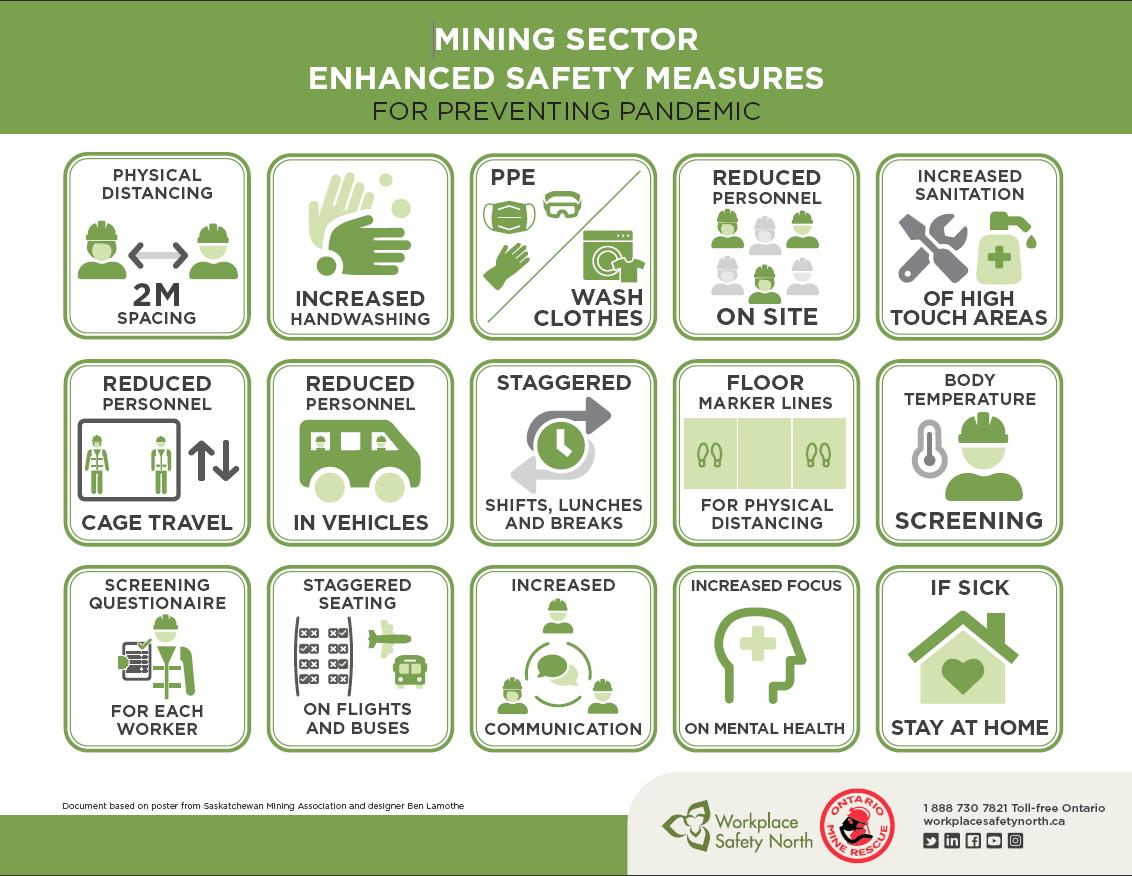List a handful of essential elements in this visual. In order to improve safety in both road and air transportation, preventive measures such as staggered seating have been implemented to reduce the risk of accidents and injuries. In order to maintain social distancing between workers, marker lines have been implemented. In areas where there is a higher probability of contact, prevention measures include increased sanitation to reduce the risk of transmission. Reducing personnel is a preventive measure taken to ensure the safety of workers in a construction site. Workers in the clothing industry often take an extra step to ensure their safety by wearing Personal Protective Equipment (PPE) and washing their clothes separately to avoid cross-contamination. 